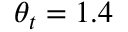<formula> <loc_0><loc_0><loc_500><loc_500>\theta _ { t } = 1 . 4</formula> 